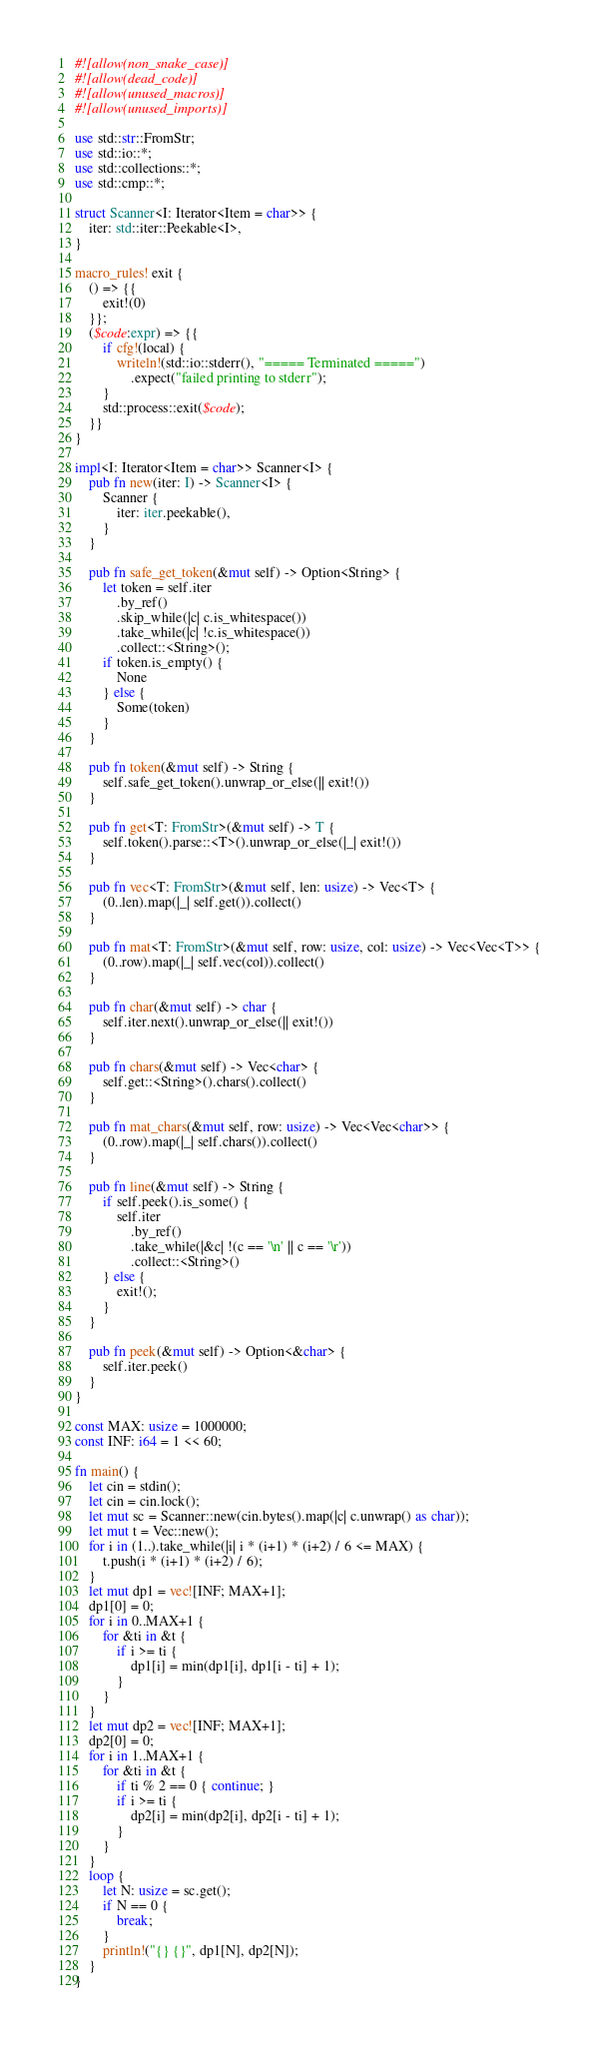<code> <loc_0><loc_0><loc_500><loc_500><_Rust_>#![allow(non_snake_case)]
#![allow(dead_code)]
#![allow(unused_macros)]
#![allow(unused_imports)]

use std::str::FromStr;
use std::io::*;
use std::collections::*;
use std::cmp::*;

struct Scanner<I: Iterator<Item = char>> {
    iter: std::iter::Peekable<I>,
}

macro_rules! exit {
    () => {{
        exit!(0)
    }};
    ($code:expr) => {{
        if cfg!(local) {
            writeln!(std::io::stderr(), "===== Terminated =====")
                .expect("failed printing to stderr");
        }
        std::process::exit($code);
    }}
}

impl<I: Iterator<Item = char>> Scanner<I> {
    pub fn new(iter: I) -> Scanner<I> {
        Scanner {
            iter: iter.peekable(),
        }
    }

    pub fn safe_get_token(&mut self) -> Option<String> {
        let token = self.iter
            .by_ref()
            .skip_while(|c| c.is_whitespace())
            .take_while(|c| !c.is_whitespace())
            .collect::<String>();
        if token.is_empty() {
            None
        } else {
            Some(token)
        }
    }

    pub fn token(&mut self) -> String {
        self.safe_get_token().unwrap_or_else(|| exit!())
    }

    pub fn get<T: FromStr>(&mut self) -> T {
        self.token().parse::<T>().unwrap_or_else(|_| exit!())
    }

    pub fn vec<T: FromStr>(&mut self, len: usize) -> Vec<T> {
        (0..len).map(|_| self.get()).collect()
    }

    pub fn mat<T: FromStr>(&mut self, row: usize, col: usize) -> Vec<Vec<T>> {
        (0..row).map(|_| self.vec(col)).collect()
    }

    pub fn char(&mut self) -> char {
        self.iter.next().unwrap_or_else(|| exit!())
    }

    pub fn chars(&mut self) -> Vec<char> {
        self.get::<String>().chars().collect()
    }

    pub fn mat_chars(&mut self, row: usize) -> Vec<Vec<char>> {
        (0..row).map(|_| self.chars()).collect()
    }

    pub fn line(&mut self) -> String {
        if self.peek().is_some() {
            self.iter
                .by_ref()
                .take_while(|&c| !(c == '\n' || c == '\r'))
                .collect::<String>()
        } else {
            exit!();
        }
    }

    pub fn peek(&mut self) -> Option<&char> {
        self.iter.peek()
    }
}

const MAX: usize = 1000000;
const INF: i64 = 1 << 60;

fn main() {
    let cin = stdin();
    let cin = cin.lock();
    let mut sc = Scanner::new(cin.bytes().map(|c| c.unwrap() as char));
    let mut t = Vec::new();
    for i in (1..).take_while(|i| i * (i+1) * (i+2) / 6 <= MAX) {
        t.push(i * (i+1) * (i+2) / 6);
    }
    let mut dp1 = vec![INF; MAX+1];
    dp1[0] = 0;
    for i in 0..MAX+1 {
        for &ti in &t {
            if i >= ti {
                dp1[i] = min(dp1[i], dp1[i - ti] + 1);
            }
        }
    }
    let mut dp2 = vec![INF; MAX+1];
    dp2[0] = 0;
    for i in 1..MAX+1 {
        for &ti in &t {
            if ti % 2 == 0 { continue; }
            if i >= ti {
                dp2[i] = min(dp2[i], dp2[i - ti] + 1);
            }
        }
    }
    loop {
        let N: usize = sc.get();
        if N == 0 {
            break;
        }
        println!("{} {}", dp1[N], dp2[N]);
    }
}

</code> 